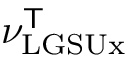Convert formula to latex. <formula><loc_0><loc_0><loc_500><loc_500>\nu _ { L G S U x } ^ { T }</formula> 